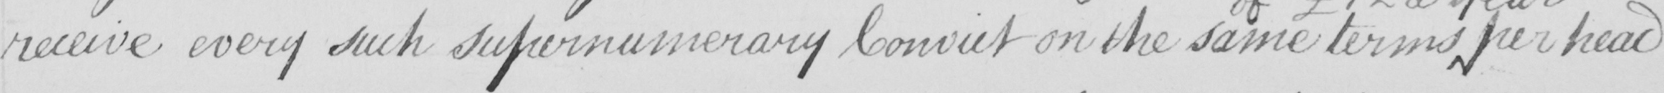Transcribe the text shown in this historical manuscript line. receive every such supernumerary Convict on the same terms per head 